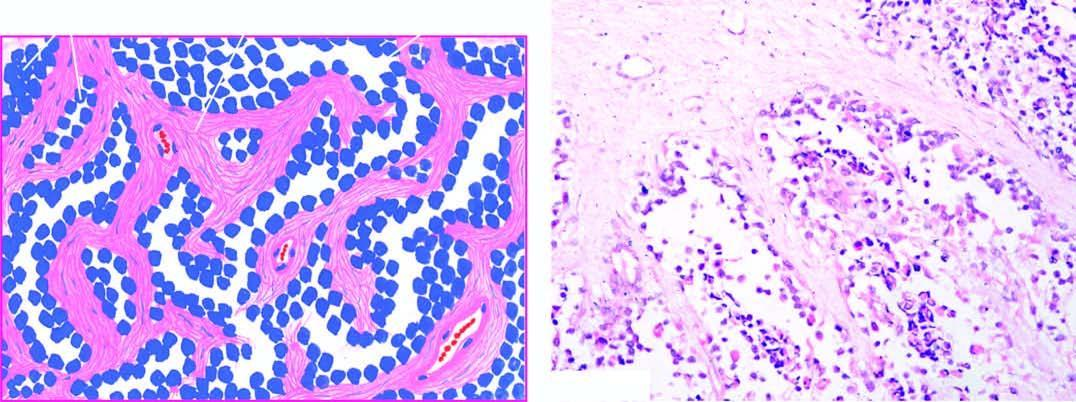what are the fibrous trabeculae lined by?
Answer the question using a single word or phrase. Small 